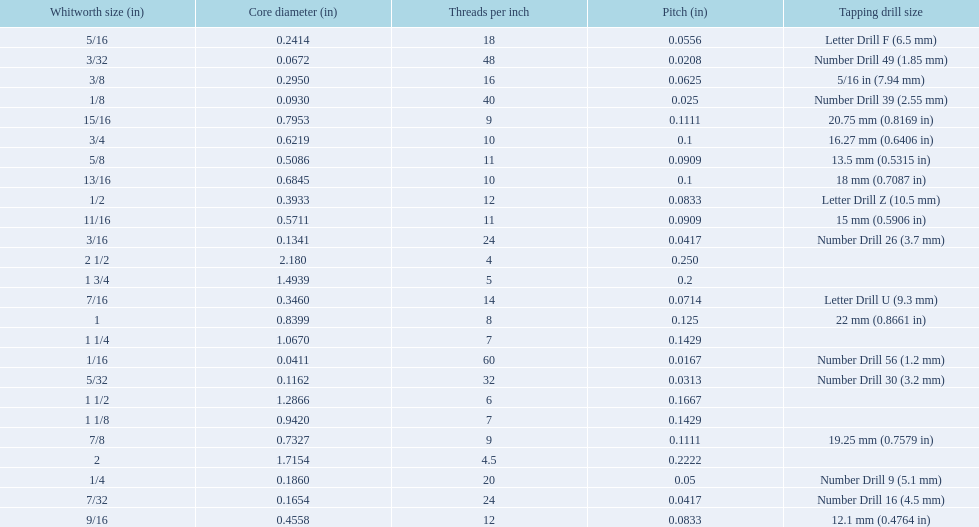What is the core diameter for the number drill 26? 0.1341. What is the whitworth size (in) for this core diameter? 3/16. 